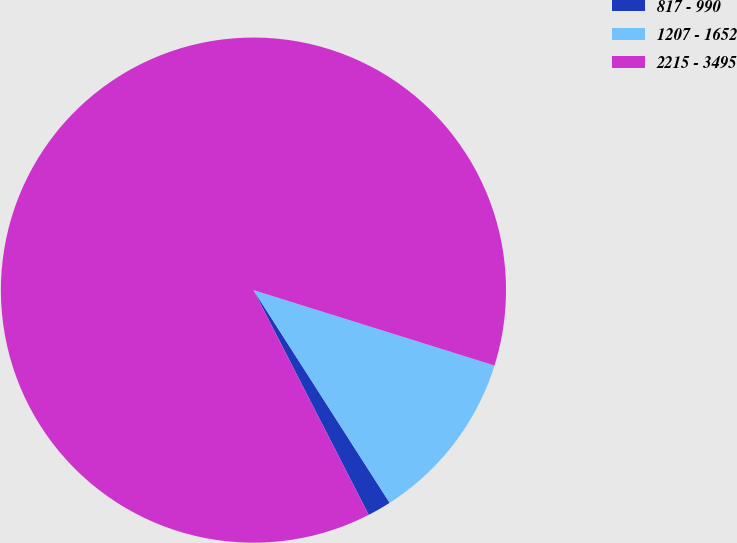Convert chart. <chart><loc_0><loc_0><loc_500><loc_500><pie_chart><fcel>817 - 990<fcel>1207 - 1652<fcel>2215 - 3495<nl><fcel>1.52%<fcel>11.11%<fcel>87.37%<nl></chart> 